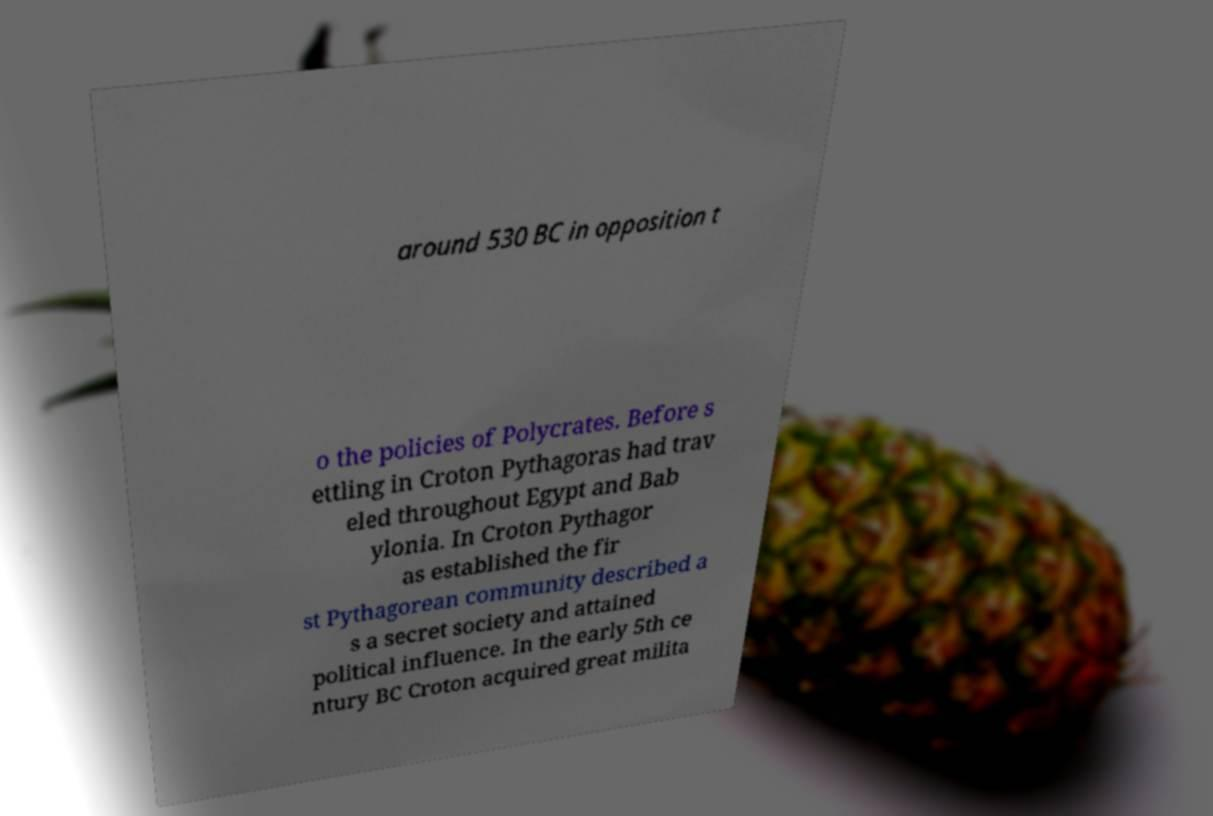Please read and relay the text visible in this image. What does it say? around 530 BC in opposition t o the policies of Polycrates. Before s ettling in Croton Pythagoras had trav eled throughout Egypt and Bab ylonia. In Croton Pythagor as established the fir st Pythagorean community described a s a secret society and attained political influence. In the early 5th ce ntury BC Croton acquired great milita 